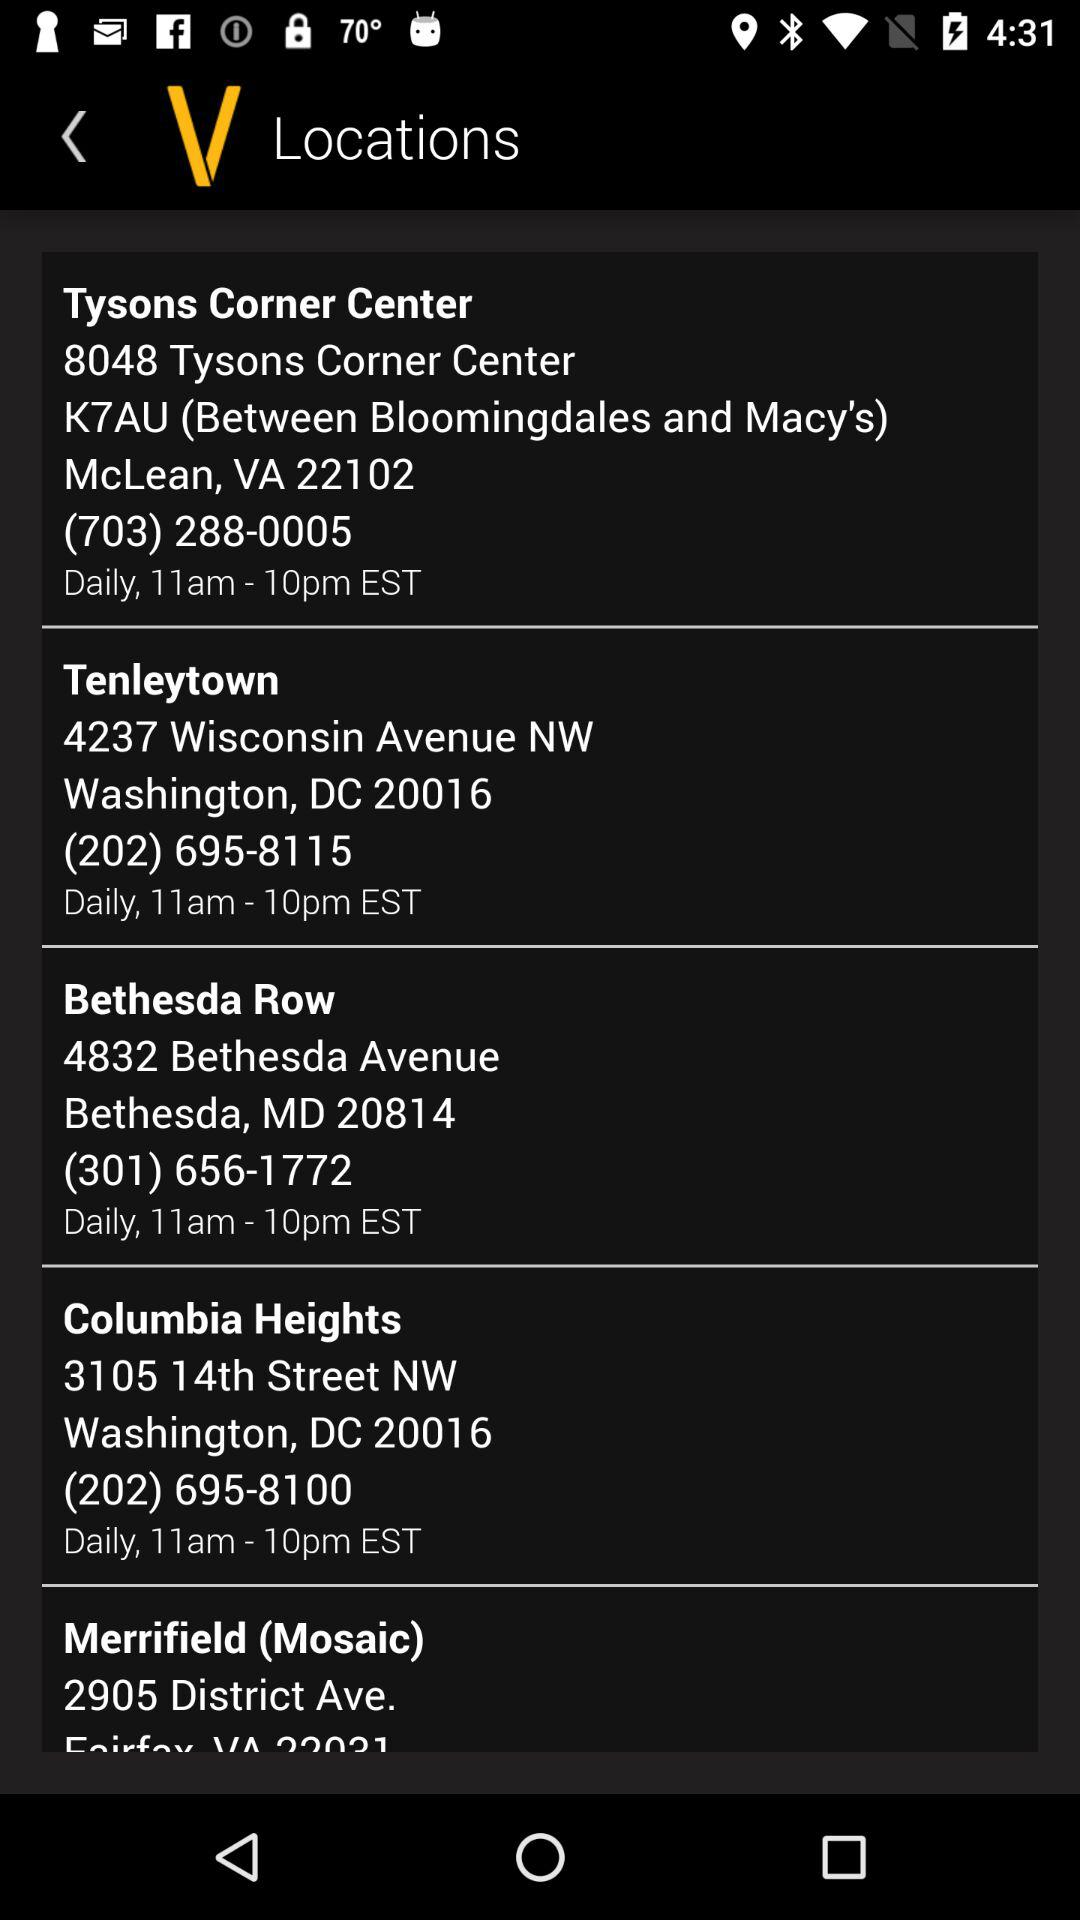What is the location of Merrifield?
When the provided information is insufficient, respond with <no answer>. <no answer> 